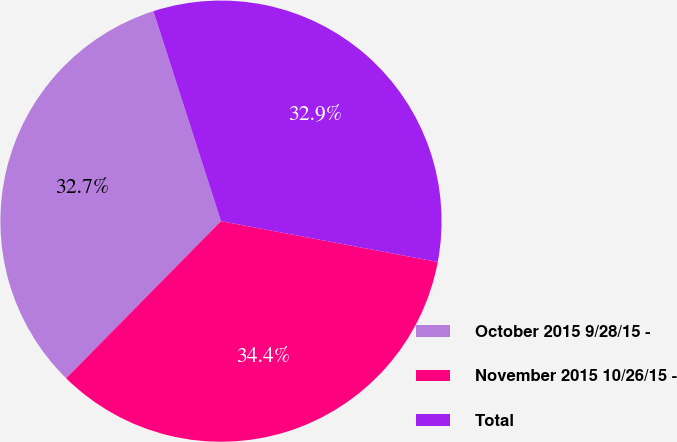<chart> <loc_0><loc_0><loc_500><loc_500><pie_chart><fcel>October 2015 9/28/15 -<fcel>November 2015 10/26/15 -<fcel>Total<nl><fcel>32.66%<fcel>34.42%<fcel>32.92%<nl></chart> 